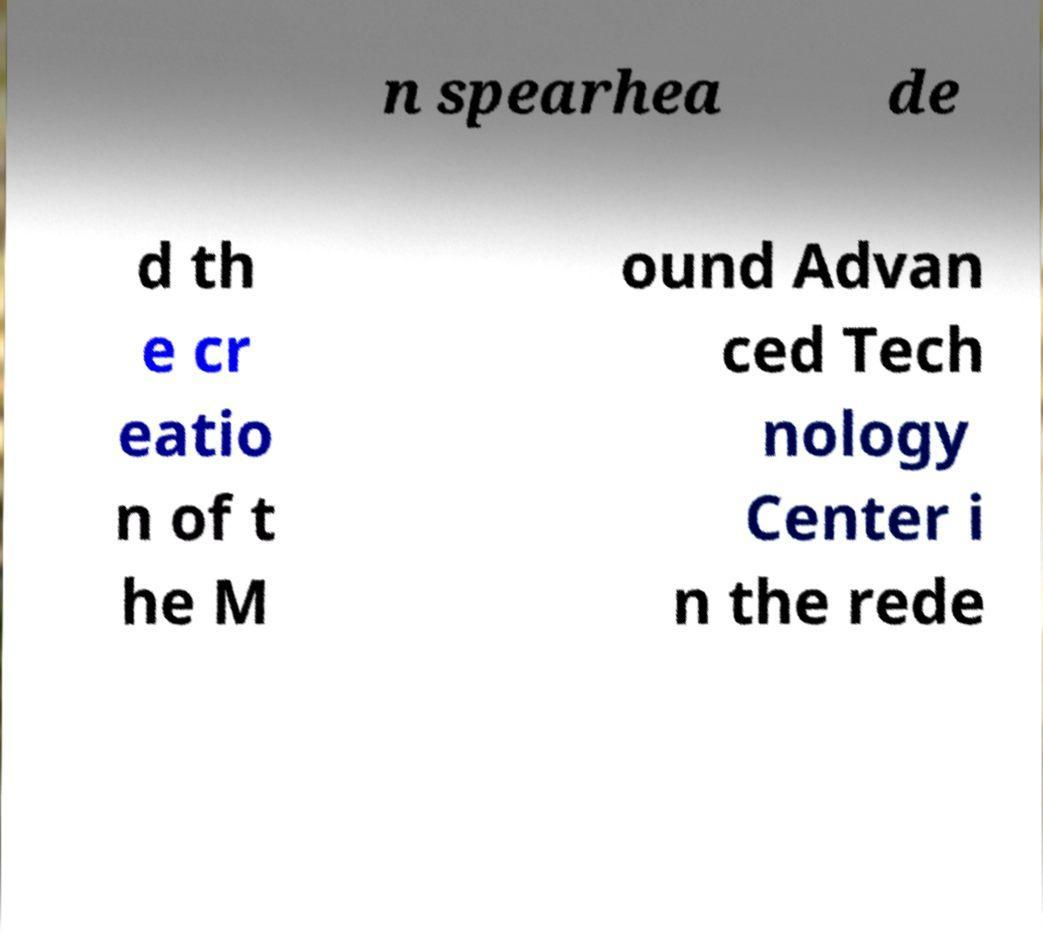I need the written content from this picture converted into text. Can you do that? n spearhea de d th e cr eatio n of t he M ound Advan ced Tech nology Center i n the rede 